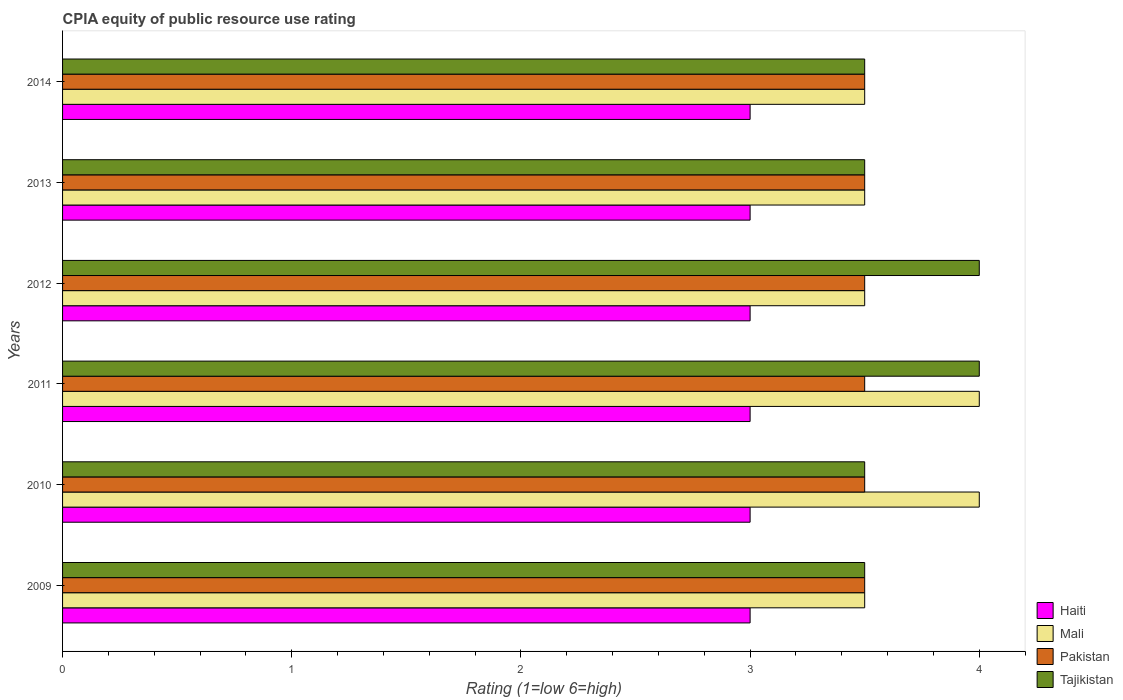How many different coloured bars are there?
Offer a terse response. 4. Are the number of bars on each tick of the Y-axis equal?
Provide a succinct answer. Yes. How many bars are there on the 3rd tick from the top?
Provide a short and direct response. 4. What is the label of the 1st group of bars from the top?
Keep it short and to the point. 2014. What is the CPIA rating in Pakistan in 2013?
Your answer should be compact. 3.5. Across all years, what is the minimum CPIA rating in Pakistan?
Provide a short and direct response. 3.5. In which year was the CPIA rating in Pakistan maximum?
Provide a short and direct response. 2009. In which year was the CPIA rating in Pakistan minimum?
Offer a very short reply. 2009. What is the total CPIA rating in Mali in the graph?
Offer a very short reply. 22. What is the difference between the CPIA rating in Pakistan in 2009 and that in 2010?
Your answer should be very brief. 0. What is the difference between the CPIA rating in Mali in 2010 and the CPIA rating in Pakistan in 2014?
Your answer should be very brief. 0.5. In the year 2013, what is the difference between the CPIA rating in Mali and CPIA rating in Pakistan?
Make the answer very short. 0. What is the ratio of the CPIA rating in Pakistan in 2010 to that in 2014?
Make the answer very short. 1. Is the difference between the CPIA rating in Mali in 2011 and 2013 greater than the difference between the CPIA rating in Pakistan in 2011 and 2013?
Keep it short and to the point. Yes. What is the difference between the highest and the second highest CPIA rating in Tajikistan?
Offer a very short reply. 0. Is the sum of the CPIA rating in Haiti in 2011 and 2013 greater than the maximum CPIA rating in Pakistan across all years?
Give a very brief answer. Yes. What does the 4th bar from the top in 2013 represents?
Keep it short and to the point. Haiti. What does the 2nd bar from the bottom in 2009 represents?
Your answer should be very brief. Mali. Is it the case that in every year, the sum of the CPIA rating in Tajikistan and CPIA rating in Pakistan is greater than the CPIA rating in Haiti?
Give a very brief answer. Yes. How many bars are there?
Provide a succinct answer. 24. Are all the bars in the graph horizontal?
Your answer should be compact. Yes. What is the difference between two consecutive major ticks on the X-axis?
Your response must be concise. 1. Does the graph contain any zero values?
Offer a very short reply. No. Does the graph contain grids?
Offer a terse response. No. What is the title of the graph?
Keep it short and to the point. CPIA equity of public resource use rating. What is the label or title of the X-axis?
Provide a short and direct response. Rating (1=low 6=high). What is the Rating (1=low 6=high) of Haiti in 2009?
Offer a terse response. 3. What is the Rating (1=low 6=high) of Pakistan in 2009?
Provide a succinct answer. 3.5. What is the Rating (1=low 6=high) of Haiti in 2010?
Keep it short and to the point. 3. What is the Rating (1=low 6=high) of Tajikistan in 2010?
Provide a short and direct response. 3.5. What is the Rating (1=low 6=high) in Mali in 2011?
Provide a short and direct response. 4. What is the Rating (1=low 6=high) of Pakistan in 2011?
Make the answer very short. 3.5. What is the Rating (1=low 6=high) in Tajikistan in 2011?
Your answer should be very brief. 4. What is the Rating (1=low 6=high) in Haiti in 2012?
Make the answer very short. 3. What is the Rating (1=low 6=high) of Mali in 2012?
Give a very brief answer. 3.5. What is the Rating (1=low 6=high) of Pakistan in 2013?
Provide a short and direct response. 3.5. What is the Rating (1=low 6=high) in Haiti in 2014?
Offer a terse response. 3. What is the Rating (1=low 6=high) in Mali in 2014?
Your response must be concise. 3.5. What is the Rating (1=low 6=high) in Pakistan in 2014?
Your response must be concise. 3.5. What is the Rating (1=low 6=high) of Tajikistan in 2014?
Give a very brief answer. 3.5. Across all years, what is the maximum Rating (1=low 6=high) of Mali?
Give a very brief answer. 4. Across all years, what is the maximum Rating (1=low 6=high) in Pakistan?
Provide a succinct answer. 3.5. Across all years, what is the minimum Rating (1=low 6=high) of Haiti?
Offer a very short reply. 3. What is the total Rating (1=low 6=high) in Haiti in the graph?
Offer a very short reply. 18. What is the total Rating (1=low 6=high) in Tajikistan in the graph?
Provide a short and direct response. 22. What is the difference between the Rating (1=low 6=high) of Haiti in 2009 and that in 2010?
Give a very brief answer. 0. What is the difference between the Rating (1=low 6=high) of Mali in 2009 and that in 2011?
Keep it short and to the point. -0.5. What is the difference between the Rating (1=low 6=high) of Pakistan in 2009 and that in 2011?
Give a very brief answer. 0. What is the difference between the Rating (1=low 6=high) of Haiti in 2009 and that in 2012?
Keep it short and to the point. 0. What is the difference between the Rating (1=low 6=high) of Pakistan in 2009 and that in 2012?
Keep it short and to the point. 0. What is the difference between the Rating (1=low 6=high) in Haiti in 2009 and that in 2013?
Offer a very short reply. 0. What is the difference between the Rating (1=low 6=high) of Mali in 2009 and that in 2013?
Offer a terse response. 0. What is the difference between the Rating (1=low 6=high) of Pakistan in 2009 and that in 2013?
Make the answer very short. 0. What is the difference between the Rating (1=low 6=high) of Tajikistan in 2009 and that in 2014?
Your answer should be very brief. 0. What is the difference between the Rating (1=low 6=high) in Mali in 2010 and that in 2011?
Your answer should be compact. 0. What is the difference between the Rating (1=low 6=high) of Pakistan in 2010 and that in 2011?
Ensure brevity in your answer.  0. What is the difference between the Rating (1=low 6=high) in Mali in 2010 and that in 2012?
Your answer should be very brief. 0.5. What is the difference between the Rating (1=low 6=high) in Pakistan in 2010 and that in 2012?
Provide a succinct answer. 0. What is the difference between the Rating (1=low 6=high) of Tajikistan in 2010 and that in 2012?
Give a very brief answer. -0.5. What is the difference between the Rating (1=low 6=high) of Mali in 2010 and that in 2013?
Offer a very short reply. 0.5. What is the difference between the Rating (1=low 6=high) in Pakistan in 2010 and that in 2013?
Make the answer very short. 0. What is the difference between the Rating (1=low 6=high) in Pakistan in 2010 and that in 2014?
Make the answer very short. 0. What is the difference between the Rating (1=low 6=high) in Haiti in 2011 and that in 2012?
Keep it short and to the point. 0. What is the difference between the Rating (1=low 6=high) in Tajikistan in 2011 and that in 2012?
Provide a short and direct response. 0. What is the difference between the Rating (1=low 6=high) of Haiti in 2011 and that in 2013?
Give a very brief answer. 0. What is the difference between the Rating (1=low 6=high) of Mali in 2011 and that in 2013?
Ensure brevity in your answer.  0.5. What is the difference between the Rating (1=low 6=high) in Tajikistan in 2011 and that in 2013?
Offer a terse response. 0.5. What is the difference between the Rating (1=low 6=high) of Mali in 2011 and that in 2014?
Your answer should be compact. 0.5. What is the difference between the Rating (1=low 6=high) of Tajikistan in 2011 and that in 2014?
Provide a succinct answer. 0.5. What is the difference between the Rating (1=low 6=high) of Mali in 2012 and that in 2013?
Provide a succinct answer. 0. What is the difference between the Rating (1=low 6=high) of Mali in 2013 and that in 2014?
Offer a terse response. 0. What is the difference between the Rating (1=low 6=high) of Haiti in 2009 and the Rating (1=low 6=high) of Tajikistan in 2010?
Your answer should be very brief. -0.5. What is the difference between the Rating (1=low 6=high) of Pakistan in 2009 and the Rating (1=low 6=high) of Tajikistan in 2010?
Offer a very short reply. 0. What is the difference between the Rating (1=low 6=high) in Haiti in 2009 and the Rating (1=low 6=high) in Pakistan in 2011?
Give a very brief answer. -0.5. What is the difference between the Rating (1=low 6=high) of Haiti in 2009 and the Rating (1=low 6=high) of Tajikistan in 2011?
Ensure brevity in your answer.  -1. What is the difference between the Rating (1=low 6=high) of Mali in 2009 and the Rating (1=low 6=high) of Pakistan in 2011?
Your answer should be very brief. 0. What is the difference between the Rating (1=low 6=high) of Mali in 2009 and the Rating (1=low 6=high) of Tajikistan in 2011?
Give a very brief answer. -0.5. What is the difference between the Rating (1=low 6=high) of Pakistan in 2009 and the Rating (1=low 6=high) of Tajikistan in 2011?
Offer a terse response. -0.5. What is the difference between the Rating (1=low 6=high) of Haiti in 2009 and the Rating (1=low 6=high) of Mali in 2012?
Make the answer very short. -0.5. What is the difference between the Rating (1=low 6=high) in Pakistan in 2009 and the Rating (1=low 6=high) in Tajikistan in 2012?
Your answer should be compact. -0.5. What is the difference between the Rating (1=low 6=high) of Mali in 2009 and the Rating (1=low 6=high) of Pakistan in 2014?
Provide a succinct answer. 0. What is the difference between the Rating (1=low 6=high) of Pakistan in 2009 and the Rating (1=low 6=high) of Tajikistan in 2014?
Your response must be concise. 0. What is the difference between the Rating (1=low 6=high) of Mali in 2010 and the Rating (1=low 6=high) of Tajikistan in 2011?
Give a very brief answer. 0. What is the difference between the Rating (1=low 6=high) in Pakistan in 2010 and the Rating (1=low 6=high) in Tajikistan in 2011?
Your answer should be compact. -0.5. What is the difference between the Rating (1=low 6=high) in Haiti in 2010 and the Rating (1=low 6=high) in Pakistan in 2012?
Give a very brief answer. -0.5. What is the difference between the Rating (1=low 6=high) in Haiti in 2010 and the Rating (1=low 6=high) in Tajikistan in 2012?
Your answer should be very brief. -1. What is the difference between the Rating (1=low 6=high) in Haiti in 2010 and the Rating (1=low 6=high) in Mali in 2013?
Your response must be concise. -0.5. What is the difference between the Rating (1=low 6=high) in Haiti in 2010 and the Rating (1=low 6=high) in Pakistan in 2013?
Ensure brevity in your answer.  -0.5. What is the difference between the Rating (1=low 6=high) of Haiti in 2010 and the Rating (1=low 6=high) of Tajikistan in 2013?
Give a very brief answer. -0.5. What is the difference between the Rating (1=low 6=high) in Mali in 2010 and the Rating (1=low 6=high) in Pakistan in 2013?
Your answer should be compact. 0.5. What is the difference between the Rating (1=low 6=high) in Mali in 2010 and the Rating (1=low 6=high) in Tajikistan in 2013?
Keep it short and to the point. 0.5. What is the difference between the Rating (1=low 6=high) in Pakistan in 2010 and the Rating (1=low 6=high) in Tajikistan in 2013?
Offer a terse response. 0. What is the difference between the Rating (1=low 6=high) in Haiti in 2010 and the Rating (1=low 6=high) in Pakistan in 2014?
Provide a short and direct response. -0.5. What is the difference between the Rating (1=low 6=high) in Haiti in 2010 and the Rating (1=low 6=high) in Tajikistan in 2014?
Offer a very short reply. -0.5. What is the difference between the Rating (1=low 6=high) of Mali in 2010 and the Rating (1=low 6=high) of Tajikistan in 2014?
Offer a very short reply. 0.5. What is the difference between the Rating (1=low 6=high) of Pakistan in 2010 and the Rating (1=low 6=high) of Tajikistan in 2014?
Give a very brief answer. 0. What is the difference between the Rating (1=low 6=high) of Haiti in 2011 and the Rating (1=low 6=high) of Pakistan in 2012?
Your answer should be very brief. -0.5. What is the difference between the Rating (1=low 6=high) of Mali in 2011 and the Rating (1=low 6=high) of Tajikistan in 2012?
Ensure brevity in your answer.  0. What is the difference between the Rating (1=low 6=high) in Pakistan in 2011 and the Rating (1=low 6=high) in Tajikistan in 2012?
Your answer should be very brief. -0.5. What is the difference between the Rating (1=low 6=high) in Mali in 2011 and the Rating (1=low 6=high) in Pakistan in 2013?
Give a very brief answer. 0.5. What is the difference between the Rating (1=low 6=high) in Mali in 2011 and the Rating (1=low 6=high) in Tajikistan in 2013?
Provide a short and direct response. 0.5. What is the difference between the Rating (1=low 6=high) of Pakistan in 2011 and the Rating (1=low 6=high) of Tajikistan in 2013?
Provide a succinct answer. 0. What is the difference between the Rating (1=low 6=high) in Haiti in 2011 and the Rating (1=low 6=high) in Mali in 2014?
Your answer should be very brief. -0.5. What is the difference between the Rating (1=low 6=high) in Mali in 2011 and the Rating (1=low 6=high) in Tajikistan in 2014?
Your answer should be compact. 0.5. What is the difference between the Rating (1=low 6=high) in Pakistan in 2011 and the Rating (1=low 6=high) in Tajikistan in 2014?
Ensure brevity in your answer.  0. What is the difference between the Rating (1=low 6=high) of Haiti in 2012 and the Rating (1=low 6=high) of Mali in 2013?
Your response must be concise. -0.5. What is the difference between the Rating (1=low 6=high) in Haiti in 2012 and the Rating (1=low 6=high) in Pakistan in 2013?
Keep it short and to the point. -0.5. What is the difference between the Rating (1=low 6=high) in Mali in 2012 and the Rating (1=low 6=high) in Pakistan in 2013?
Your response must be concise. 0. What is the difference between the Rating (1=low 6=high) in Haiti in 2012 and the Rating (1=low 6=high) in Mali in 2014?
Make the answer very short. -0.5. What is the difference between the Rating (1=low 6=high) in Haiti in 2012 and the Rating (1=low 6=high) in Pakistan in 2014?
Make the answer very short. -0.5. What is the difference between the Rating (1=low 6=high) of Haiti in 2012 and the Rating (1=low 6=high) of Tajikistan in 2014?
Your answer should be compact. -0.5. What is the difference between the Rating (1=low 6=high) of Mali in 2012 and the Rating (1=low 6=high) of Pakistan in 2014?
Offer a very short reply. 0. What is the difference between the Rating (1=low 6=high) of Haiti in 2013 and the Rating (1=low 6=high) of Mali in 2014?
Keep it short and to the point. -0.5. What is the difference between the Rating (1=low 6=high) of Haiti in 2013 and the Rating (1=low 6=high) of Pakistan in 2014?
Give a very brief answer. -0.5. What is the average Rating (1=low 6=high) of Mali per year?
Keep it short and to the point. 3.67. What is the average Rating (1=low 6=high) in Tajikistan per year?
Your response must be concise. 3.67. In the year 2009, what is the difference between the Rating (1=low 6=high) of Haiti and Rating (1=low 6=high) of Mali?
Provide a short and direct response. -0.5. In the year 2009, what is the difference between the Rating (1=low 6=high) in Mali and Rating (1=low 6=high) in Pakistan?
Make the answer very short. 0. In the year 2009, what is the difference between the Rating (1=low 6=high) of Pakistan and Rating (1=low 6=high) of Tajikistan?
Your answer should be very brief. 0. In the year 2010, what is the difference between the Rating (1=low 6=high) in Haiti and Rating (1=low 6=high) in Mali?
Your answer should be compact. -1. In the year 2010, what is the difference between the Rating (1=low 6=high) in Haiti and Rating (1=low 6=high) in Tajikistan?
Offer a terse response. -0.5. In the year 2010, what is the difference between the Rating (1=low 6=high) in Mali and Rating (1=low 6=high) in Pakistan?
Your answer should be very brief. 0.5. In the year 2010, what is the difference between the Rating (1=low 6=high) of Mali and Rating (1=low 6=high) of Tajikistan?
Your answer should be very brief. 0.5. In the year 2011, what is the difference between the Rating (1=low 6=high) in Haiti and Rating (1=low 6=high) in Mali?
Make the answer very short. -1. In the year 2011, what is the difference between the Rating (1=low 6=high) of Pakistan and Rating (1=low 6=high) of Tajikistan?
Give a very brief answer. -0.5. In the year 2012, what is the difference between the Rating (1=low 6=high) in Haiti and Rating (1=low 6=high) in Tajikistan?
Keep it short and to the point. -1. In the year 2012, what is the difference between the Rating (1=low 6=high) in Mali and Rating (1=low 6=high) in Pakistan?
Give a very brief answer. 0. In the year 2013, what is the difference between the Rating (1=low 6=high) of Haiti and Rating (1=low 6=high) of Mali?
Ensure brevity in your answer.  -0.5. In the year 2013, what is the difference between the Rating (1=low 6=high) in Haiti and Rating (1=low 6=high) in Tajikistan?
Make the answer very short. -0.5. In the year 2013, what is the difference between the Rating (1=low 6=high) in Mali and Rating (1=low 6=high) in Pakistan?
Your answer should be compact. 0. In the year 2013, what is the difference between the Rating (1=low 6=high) in Mali and Rating (1=low 6=high) in Tajikistan?
Offer a very short reply. 0. In the year 2013, what is the difference between the Rating (1=low 6=high) in Pakistan and Rating (1=low 6=high) in Tajikistan?
Provide a succinct answer. 0. In the year 2014, what is the difference between the Rating (1=low 6=high) in Haiti and Rating (1=low 6=high) in Pakistan?
Offer a very short reply. -0.5. In the year 2014, what is the difference between the Rating (1=low 6=high) of Mali and Rating (1=low 6=high) of Pakistan?
Your answer should be very brief. 0. What is the ratio of the Rating (1=low 6=high) in Pakistan in 2009 to that in 2010?
Make the answer very short. 1. What is the ratio of the Rating (1=low 6=high) of Tajikistan in 2009 to that in 2010?
Your answer should be very brief. 1. What is the ratio of the Rating (1=low 6=high) in Mali in 2009 to that in 2011?
Your answer should be very brief. 0.88. What is the ratio of the Rating (1=low 6=high) of Pakistan in 2009 to that in 2011?
Provide a succinct answer. 1. What is the ratio of the Rating (1=low 6=high) in Tajikistan in 2009 to that in 2011?
Provide a succinct answer. 0.88. What is the ratio of the Rating (1=low 6=high) of Haiti in 2009 to that in 2012?
Provide a succinct answer. 1. What is the ratio of the Rating (1=low 6=high) of Mali in 2009 to that in 2012?
Your answer should be very brief. 1. What is the ratio of the Rating (1=low 6=high) of Pakistan in 2009 to that in 2012?
Give a very brief answer. 1. What is the ratio of the Rating (1=low 6=high) in Haiti in 2009 to that in 2013?
Your answer should be compact. 1. What is the ratio of the Rating (1=low 6=high) of Mali in 2009 to that in 2013?
Offer a terse response. 1. What is the ratio of the Rating (1=low 6=high) of Tajikistan in 2009 to that in 2013?
Provide a succinct answer. 1. What is the ratio of the Rating (1=low 6=high) in Haiti in 2009 to that in 2014?
Make the answer very short. 1. What is the ratio of the Rating (1=low 6=high) in Tajikistan in 2009 to that in 2014?
Your response must be concise. 1. What is the ratio of the Rating (1=low 6=high) of Haiti in 2010 to that in 2011?
Keep it short and to the point. 1. What is the ratio of the Rating (1=low 6=high) in Mali in 2010 to that in 2011?
Make the answer very short. 1. What is the ratio of the Rating (1=low 6=high) in Tajikistan in 2010 to that in 2011?
Your response must be concise. 0.88. What is the ratio of the Rating (1=low 6=high) of Mali in 2010 to that in 2012?
Give a very brief answer. 1.14. What is the ratio of the Rating (1=low 6=high) of Tajikistan in 2010 to that in 2012?
Keep it short and to the point. 0.88. What is the ratio of the Rating (1=low 6=high) in Haiti in 2010 to that in 2013?
Keep it short and to the point. 1. What is the ratio of the Rating (1=low 6=high) of Tajikistan in 2010 to that in 2013?
Offer a very short reply. 1. What is the ratio of the Rating (1=low 6=high) of Pakistan in 2010 to that in 2014?
Provide a short and direct response. 1. What is the ratio of the Rating (1=low 6=high) of Mali in 2011 to that in 2012?
Offer a very short reply. 1.14. What is the ratio of the Rating (1=low 6=high) in Tajikistan in 2011 to that in 2012?
Provide a short and direct response. 1. What is the ratio of the Rating (1=low 6=high) in Pakistan in 2011 to that in 2013?
Your answer should be compact. 1. What is the ratio of the Rating (1=low 6=high) of Tajikistan in 2011 to that in 2013?
Keep it short and to the point. 1.14. What is the ratio of the Rating (1=low 6=high) in Haiti in 2011 to that in 2014?
Ensure brevity in your answer.  1. What is the ratio of the Rating (1=low 6=high) of Haiti in 2012 to that in 2013?
Make the answer very short. 1. What is the ratio of the Rating (1=low 6=high) of Tajikistan in 2012 to that in 2014?
Your answer should be compact. 1.14. What is the difference between the highest and the second highest Rating (1=low 6=high) of Haiti?
Offer a terse response. 0. What is the difference between the highest and the second highest Rating (1=low 6=high) of Tajikistan?
Make the answer very short. 0. What is the difference between the highest and the lowest Rating (1=low 6=high) in Pakistan?
Give a very brief answer. 0. What is the difference between the highest and the lowest Rating (1=low 6=high) of Tajikistan?
Offer a very short reply. 0.5. 